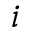<formula> <loc_0><loc_0><loc_500><loc_500>i</formula> 